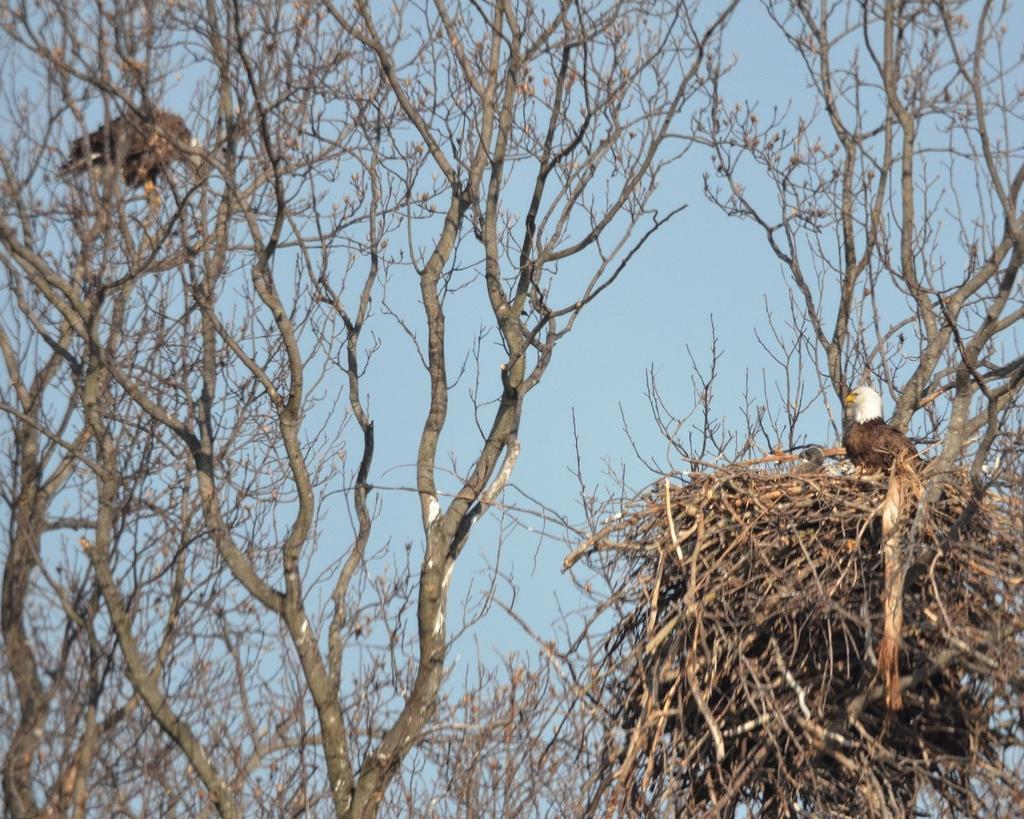Please provide a concise description of this image. On the right side of the image there is a bird on the nest. On the left side of the image there is a bird on the branch of a tree. Around them there are trees with dried branches. In the background of the image there is sky. 